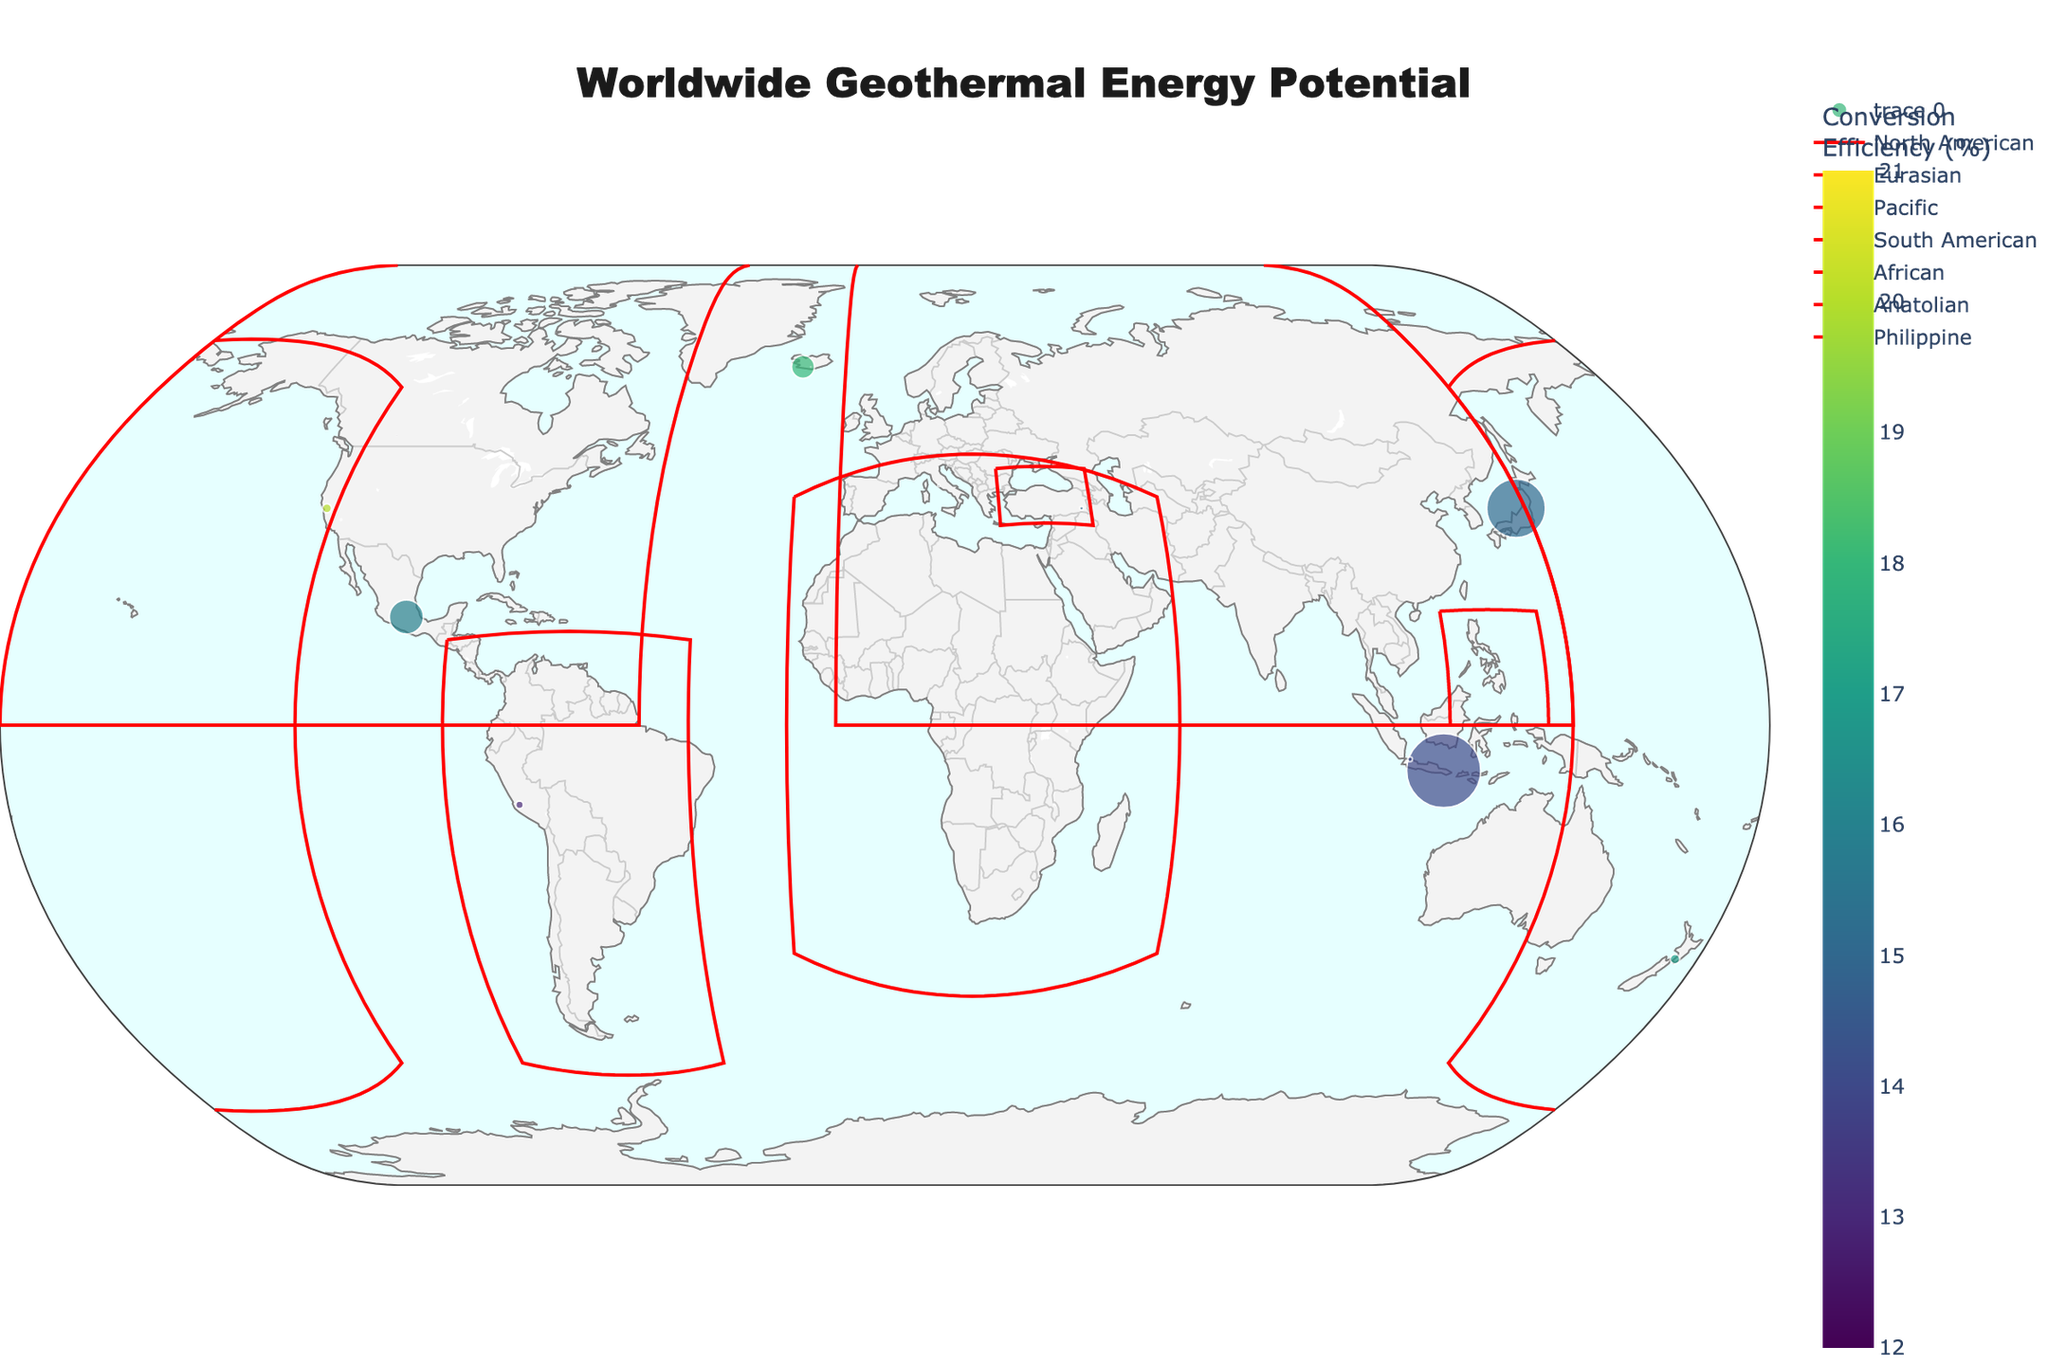What is the overall title of the figure? The title is displayed at the top center of the figure and reads "Worldwide Geothermal Energy Potential".
Answer: Worldwide Geothermal Energy Potential How is the geothermal potential visually represented on the map? The geothermal potential is represented by the size of the markers. Larger markers correspond to higher geothermal potential in gigawatts (GW).
Answer: By marker size Which region has the highest conversion efficiency for geothermal energy according to the figure? We need to look at the color scale of the markers, where higher conversion efficiency percentages are indicated by lighter colors. The region with a marker in the lightest color corresponds to the highest efficiency. This appears to be Reykjanes, Iceland, with a conversion efficiency of 21%.
Answer: Reykjanes, Iceland How many regions fall under the Eurasian tectonic plate and what is their total geothermal potential? We can count the number of markers located in regions under the Eurasian tectonic plate and then sum their geothermal potentials. The regions are Japan, Indonesia, and Italy, with potentials of 23.0, 29.0, and 0.9 GW respectively. Adding these gives 23.0 + 29.0 + 0.9 = 52.9 GW.
Answer: Three regions; 52.9 GW Compare the geothermal potential of Iceland and New Zealand. Which one has a higher potential and by how much? We look at the marker sizes and hover text for Iceland (9.0 GW) and New Zealand (3.8 GW). Iceland has a higher geothermal potential. The difference is 9.0 - 3.8 = 5.2 GW.
Answer: Iceland by 5.2 GW What is the average conversion efficiency (%) of all the regions depicted in the figure? To calculate the average, we sum the conversion efficiencies of all regions and divide by the number of regions: (18 + 15 + 17 + 14 + 16 + 20 + 13 + 16 + 14 + 15 + 14 + 12 + 18 + 19 + 21)/15 = 242/15 ≈ 16.13%.
Answer: 16.13% Which region has the smallest marker size and what could this indicate about its geothermal potential? The smallest marker size corresponds to the region with the least geothermal potential. According to the figure, Alberta, Canada and Reykjanes, Iceland have the smallest markers, each representing a potential of 0.1 GW.
Answer: Alberta, Canada and Reykjanes, Iceland In terms of geothermal energy potential, which tectonic plate has the greatest concentration of potential according to the figure? We need to sum the geothermal potentials of regions falling under each tectonic plate. Summing for Eurasian, North American, Pacific, South American, and African tectonic plates shows Eurasian with 52.9 GW, North American with 26.8 GW, Pacific with 4.7 GW, South American with 3.0 GW, and African with 0.7 GW. Eurasian has the greatest potential.
Answer: Eurasian How is geothermal conversion efficiency represented within the markers on the map? The conversion efficiency is represented by the color of the markers. The lighter the color, the higher the conversion efficiency.
Answer: By color of markers Identify the region with the highest geothermal potential and state the corresponding conversion efficiency. We hover over the markers to find the region with the highest potential, which is Indonesia with 29.0 GW, and see its conversion efficiency is 14%.
Answer: Indonesia, 14% 